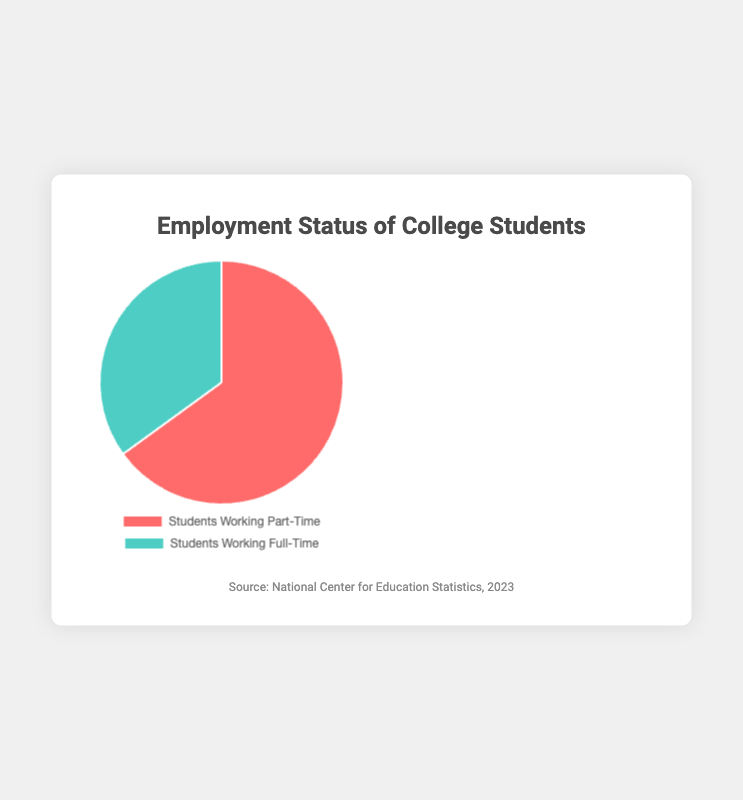What percentage of college students are working part-time? To determine the percentage of students working part-time, look at the segment labeled "Students Working Part-Time" in the pie chart. It's given as 65%.
Answer: 65% What percentage of college students are working full-time? The percentage of students working full-time is displayed on the chart segment labeled "Students Working Full-Time," which is 35%.
Answer: 35% Which employment status has a higher percentage of college students? Compare the segments "Students Working Part-Time" and "Students Working Full-Time." The former has 65%, and the latter has 35%. Therefore, a higher percentage of students are working part-time.
Answer: Students Working Part-Time What is the ratio of students working part-time to those working full-time? To find the ratio, divide the percentage of students working part-time by the percentage working full-time. This gives us 65% / 35%. Simplifying, we get roughly 1.86:1.
Answer: 1.86:1 What is the total percentage represented by students working part-time and full-time combined? Sum the given percentages for both segments: 65% + 35%. The combined total is 100%.
Answer: 100% How much more common is part-time work compared to full-time work among college students? Calculate the difference between the percentage of students working part-time and those working full-time: 65% - 35% = 30%. So, part-time work is 30% more common.
Answer: 30% What are the colors used to represent the different employment statuses in the chart? The chart uses colors to differentiate between segments: students working part-time are represented in red, and students working full-time are represented in green.
Answer: Red and Green Which segment represents a larger portion of the pie chart? Visually compare the sizes of both segments. The "Students Working Part-Time" segment is larger, occupying 65% of the pie chart.
Answer: Students Working Part-Time 